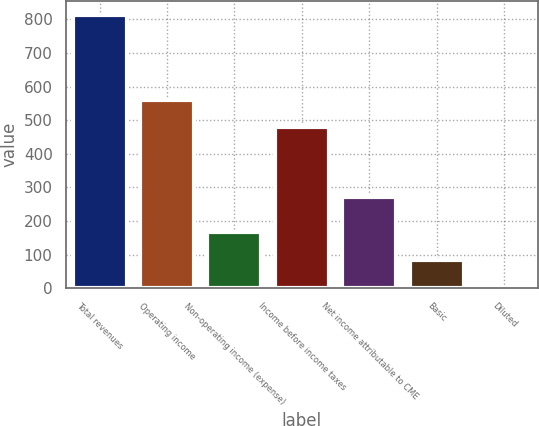<chart> <loc_0><loc_0><loc_500><loc_500><bar_chart><fcel>Total revenues<fcel>Operating income<fcel>Non-operating income (expense)<fcel>Income before income taxes<fcel>Net income attributable to CME<fcel>Basic<fcel>Diluted<nl><fcel>813.9<fcel>561.08<fcel>166.07<fcel>480.1<fcel>270.7<fcel>85.09<fcel>4.11<nl></chart> 